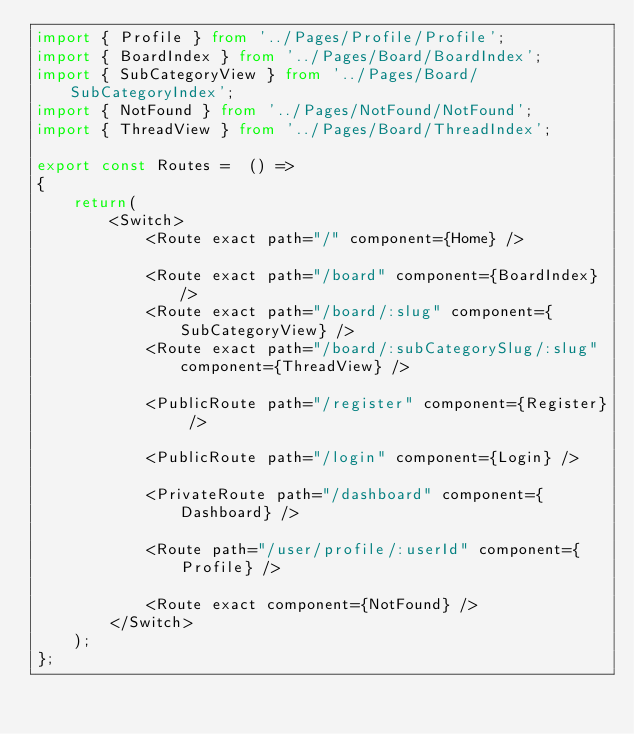<code> <loc_0><loc_0><loc_500><loc_500><_TypeScript_>import { Profile } from '../Pages/Profile/Profile';
import { BoardIndex } from '../Pages/Board/BoardIndex';
import { SubCategoryView } from '../Pages/Board/SubCategoryIndex';
import { NotFound } from '../Pages/NotFound/NotFound';
import { ThreadView } from '../Pages/Board/ThreadIndex';

export const Routes =  () =>
{
    return(
        <Switch>
            <Route exact path="/" component={Home} />

            <Route exact path="/board" component={BoardIndex} />
            <Route exact path="/board/:slug" component={SubCategoryView} />
            <Route exact path="/board/:subCategorySlug/:slug" component={ThreadView} />

            <PublicRoute path="/register" component={Register} />

            <PublicRoute path="/login" component={Login} />

            <PrivateRoute path="/dashboard" component={Dashboard} />

            <Route path="/user/profile/:userId" component={Profile} />

            <Route exact component={NotFound} />
        </Switch>
    );
};
</code> 